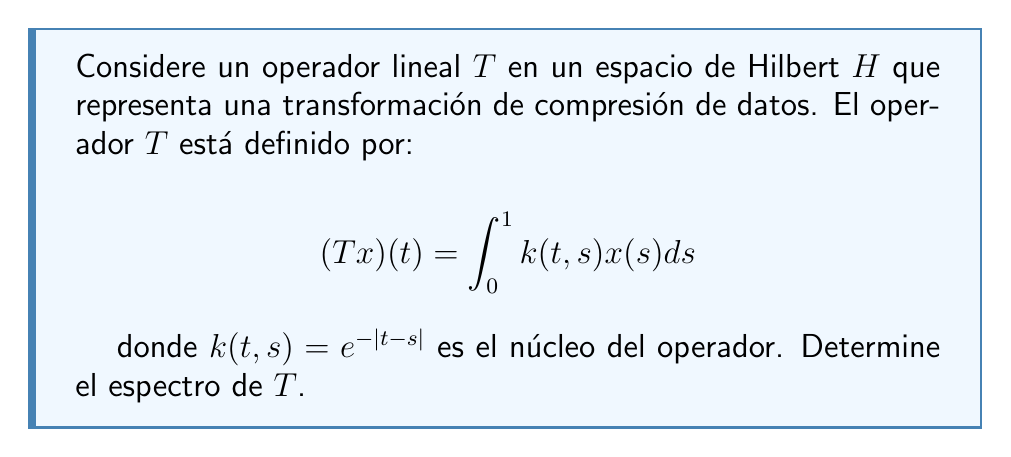Give your solution to this math problem. Para determinar el espectro del operador $T$, seguiremos estos pasos:

1) Primero, notemos que $T$ es un operador integral compacto en $L^2[0,1]$. Por el teorema espectral para operadores compactos autoadjuntos, el espectro de $T$ consiste en $0$ y sus valores propios.

2) Para encontrar los valores propios, necesitamos resolver la ecuación de valores propios:

   $$Tx = \lambda x$$

   que en forma integral es:

   $$\int_0^1 e^{-|t-s|}x(s)ds = \lambda x(t)$$

3) Diferenciando dos veces esta ecuación con respecto a $t$, obtenemos:

   $$\frac{d^2x}{dt^2} = x$$

4) La solución general de esta ecuación diferencial es:

   $$x(t) = A\cosh(t) + B\sinh(t)$$

5) Sustituyendo esta solución en la ecuación integral original y usando las propiedades de las funciones hiperbólicas, llegamos a:

   $$\frac{A}{2}(\cosh(1)-1) + \frac{B}{2}\sinh(1) = \lambda A$$
   $$\frac{A}{2}\sinh(1) + \frac{B}{2}(\cosh(1)-1) = \lambda B$$

6) Para que exista una solución no trivial, el determinante de este sistema debe ser cero:

   $$\det\begin{pmatrix}
   \frac{1}{2}(\cosh(1)-1) - \lambda & \frac{1}{2}\sinh(1) \\
   \frac{1}{2}\sinh(1) & \frac{1}{2}(\cosh(1)-1) - \lambda
   \end{pmatrix} = 0$$

7) Resolviendo esta ecuación, obtenemos dos valores propios:

   $$\lambda_1 = 1 \quad \text{y} \quad \lambda_2 = \tanh(1/2)$$

8) Además, como $T$ es compacto, $0$ está en el espectro continuo.

Por lo tanto, el espectro de $T$ es $\{0, \tanh(1/2), 1\}$.
Answer: El espectro del operador $T$ es $\sigma(T) = \{0, \tanh(1/2), 1\}$. 